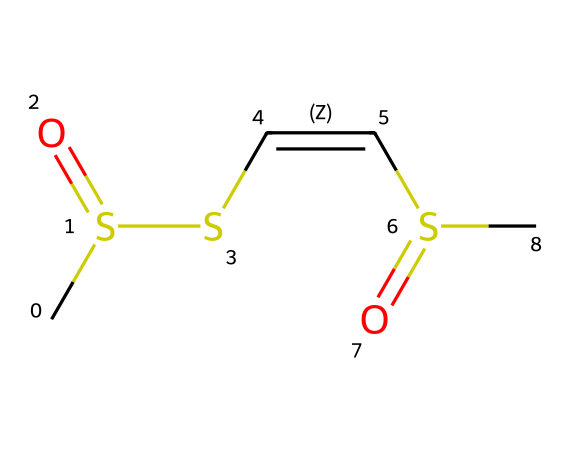What is the general chemical structure of allicin? The structure features a thiosulfinate functional group characterized by the presence of sulfur atoms connected to a carbon chain. The specific arrangement includes a double bond between two carbon atoms.
Answer: thiosulfinate How many sulfur atoms are present in allicin? By examining the SMILES representation, we can identify two sulfur atoms in the structure as indicated by the "S" characters.
Answer: two What type of bond is present between the two central carbon atoms in allicin? The presence of the character "/" indicates a cis-cis double bond between the two carbon atoms, which is characteristic of allicin's unsaturated nature.
Answer: double What is the oxidation state of the sulfur in allicin? The sulfur atoms are in a higher oxidation state due to their bonding as thiosulfinate and involvement in the double bond structure, typically relating to sulfoxides or sulfonyl groups.
Answer: +4 How many carbons are in the allicin molecule? Counting the carbon atoms in the SMILES structure, we identify a total of four carbon atoms interconnected in the chemical backbone.
Answer: four Does allicin contain any functional groups? Yes, allicin contains the thiosulfinate functional group, which is defined by the presence of sulfur and oxygen, specifically seen in its bonding configuration.
Answer: thiosulfinate 